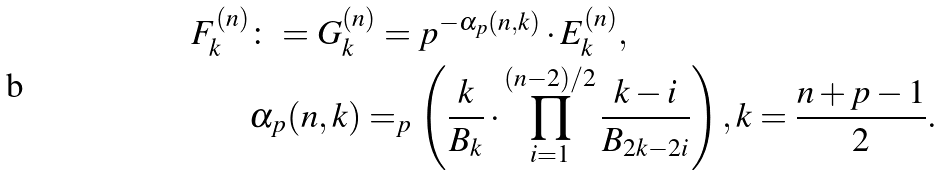Convert formula to latex. <formula><loc_0><loc_0><loc_500><loc_500>F _ { k } ^ { ( n ) } & \colon = G _ { k } ^ { ( n ) } = p ^ { - \alpha _ { p } ( n , k ) } \cdot E _ { k } ^ { ( n ) } , \\ & \alpha _ { p } ( n , k ) = _ { p } \left ( \frac { k } { B _ { k } } \cdot \prod _ { i = 1 } ^ { ( n - 2 ) / 2 } \frac { k - i } { B _ { 2 k - 2 i } } \right ) , k = \frac { n + p - 1 } { 2 } .</formula> 